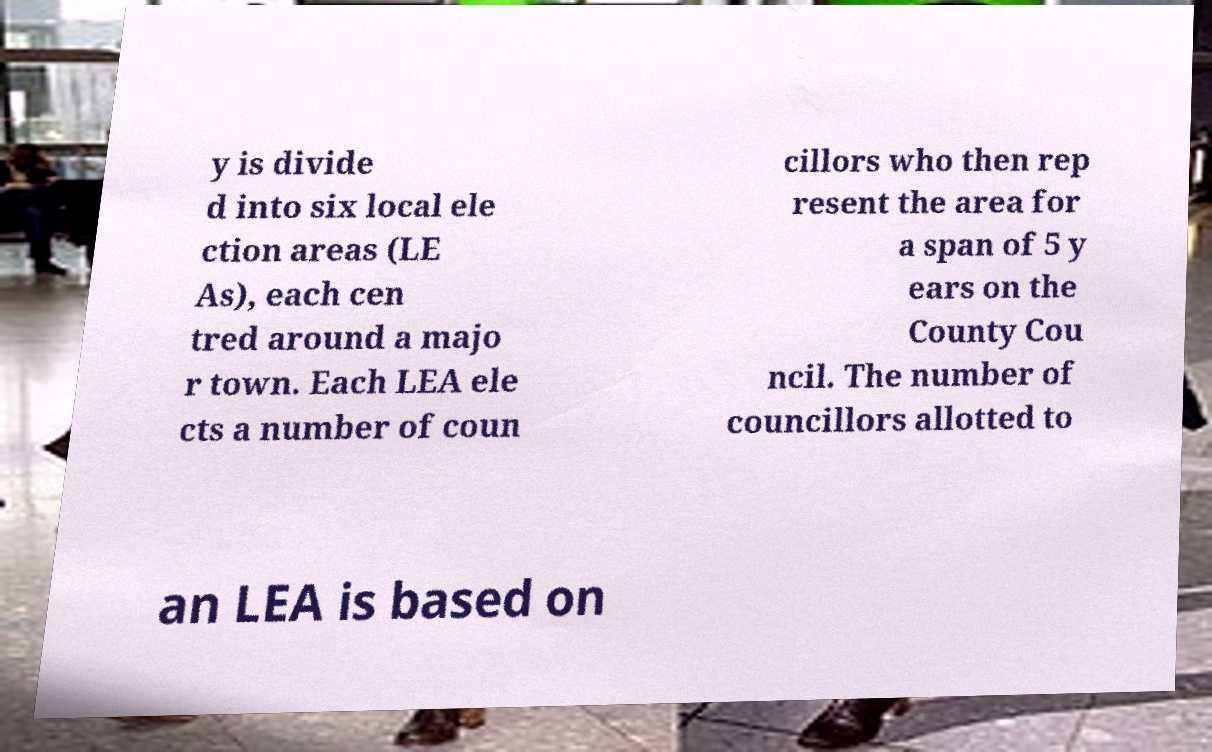Please identify and transcribe the text found in this image. y is divide d into six local ele ction areas (LE As), each cen tred around a majo r town. Each LEA ele cts a number of coun cillors who then rep resent the area for a span of 5 y ears on the County Cou ncil. The number of councillors allotted to an LEA is based on 